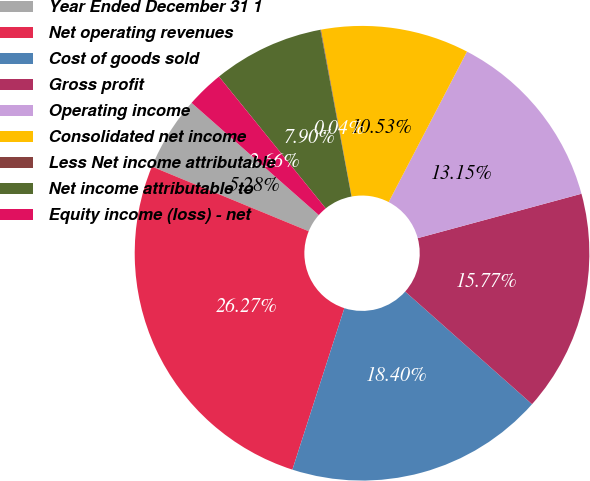Convert chart to OTSL. <chart><loc_0><loc_0><loc_500><loc_500><pie_chart><fcel>Year Ended December 31 1<fcel>Net operating revenues<fcel>Cost of goods sold<fcel>Gross profit<fcel>Operating income<fcel>Consolidated net income<fcel>Less Net income attributable<fcel>Net income attributable to<fcel>Equity income (loss) - net<nl><fcel>5.28%<fcel>26.27%<fcel>18.4%<fcel>15.77%<fcel>13.15%<fcel>10.53%<fcel>0.04%<fcel>7.9%<fcel>2.66%<nl></chart> 